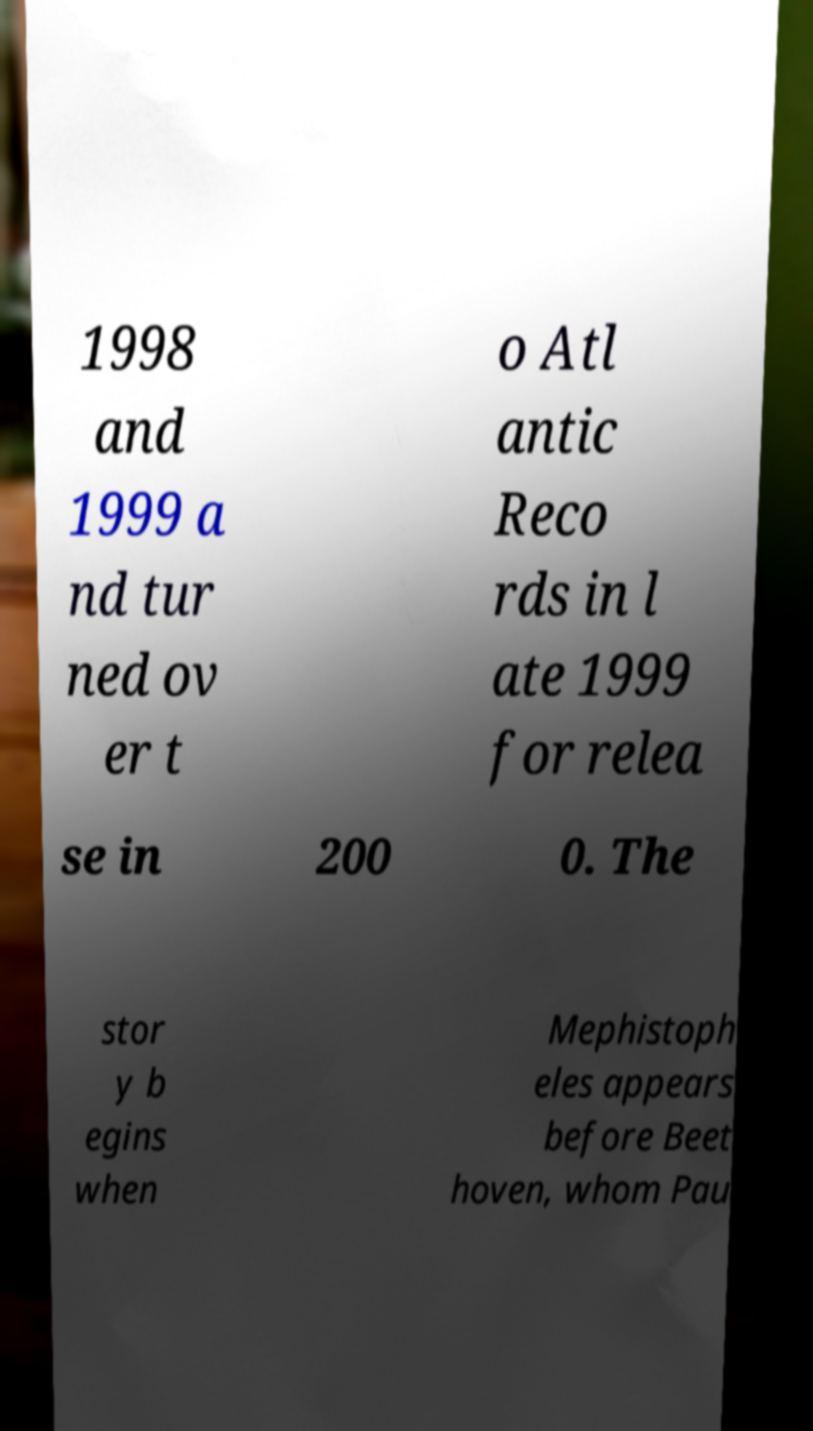There's text embedded in this image that I need extracted. Can you transcribe it verbatim? 1998 and 1999 a nd tur ned ov er t o Atl antic Reco rds in l ate 1999 for relea se in 200 0. The stor y b egins when Mephistoph eles appears before Beet hoven, whom Pau 